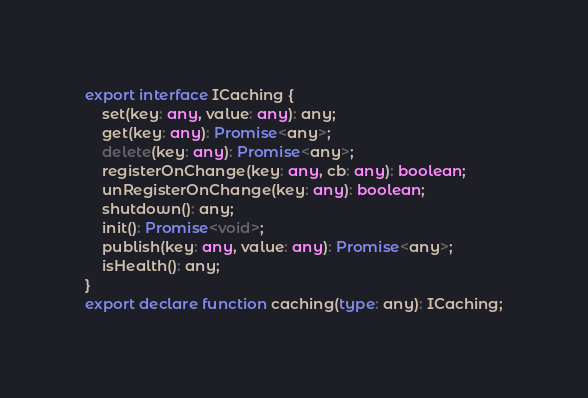Convert code to text. <code><loc_0><loc_0><loc_500><loc_500><_TypeScript_>export interface ICaching {
    set(key: any, value: any): any;
    get(key: any): Promise<any>;
    delete(key: any): Promise<any>;
    registerOnChange(key: any, cb: any): boolean;
    unRegisterOnChange(key: any): boolean;
    shutdown(): any;
    init(): Promise<void>;
    publish(key: any, value: any): Promise<any>;
    isHealth(): any;
}
export declare function caching(type: any): ICaching;
</code> 